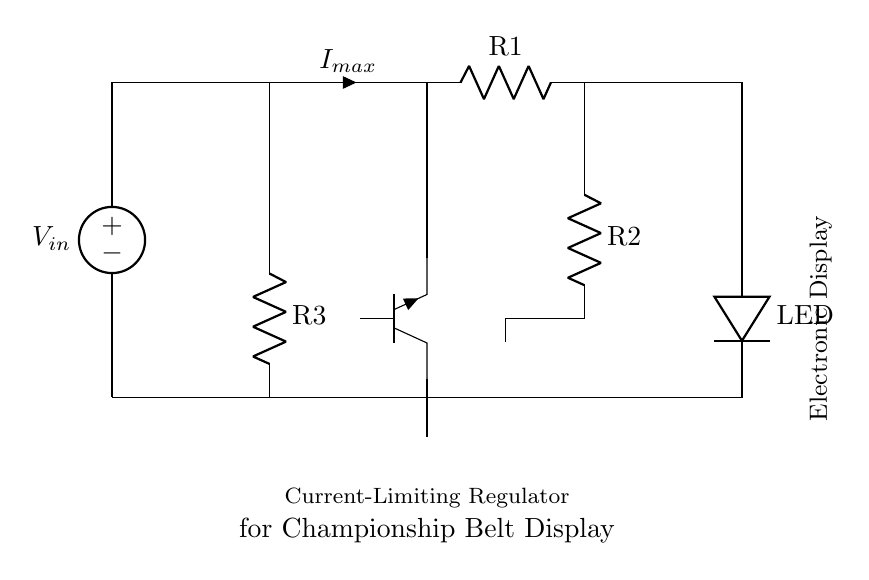What is the input voltage of this circuit? The input voltage, labeled as V_in, is indicated at the top-left of the circuit diagram, where the voltage source is connected.
Answer: V_in What component limits the maximum current? The component that limits the maximum current is an NPN transistor (noted as Tnpn), which controls the flow of current based on the input conditions.
Answer: NPN transistor How many resistors are in this circuit? There are three resistors in the circuit, labeled as R1, R2, and R3. They are used to control current and voltage in various parts of the circuit.
Answer: 3 What does the LED indicate? The LED serves as an indicator; when lit, it shows that current is flowing through the circuit, which confirms that the regulator is functioning correctly.
Answer: Indicator What is the purpose of R2 in the circuit? R2 functions as a current-limiting resistor to reduce the current passing through the transistor as well as protect the LED from excessive current, thereby preventing damage.
Answer: Current-limiting resistor Which component protects the electronic display? The NPN transistor acts as a switch that ensures that only the appropriate current reaches the electronic display, protecting it from overcurrent conditions.
Answer: NPN transistor What is connected to the output of this regulator circuit? The output of this regulator is connected to an electronic display, which receives regulated voltage and current for proper operation.
Answer: Electronic display 